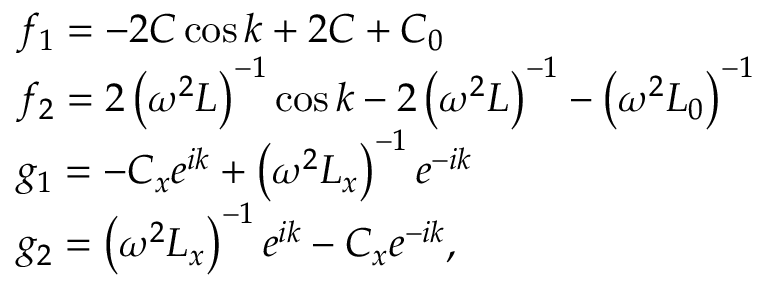<formula> <loc_0><loc_0><loc_500><loc_500>\begin{array} { r l } & { f _ { 1 } = - 2 C \cos k + 2 C + C _ { 0 } } \\ & { f _ { 2 } = 2 \left ( \omega ^ { 2 } L \right ) ^ { - 1 } \cos k - 2 \left ( \omega ^ { 2 } L \right ) ^ { - 1 } - \left ( \omega ^ { 2 } L _ { 0 } \right ) ^ { - 1 } } \\ & { g _ { 1 } = - C _ { x } e ^ { i k } + \left ( \omega ^ { 2 } L _ { x } \right ) ^ { - 1 } e ^ { - i k } } \\ & { g _ { 2 } = \left ( \omega ^ { 2 } L _ { x } \right ) ^ { - 1 } e ^ { i k } - C _ { x } e ^ { - i k } , } \end{array}</formula> 